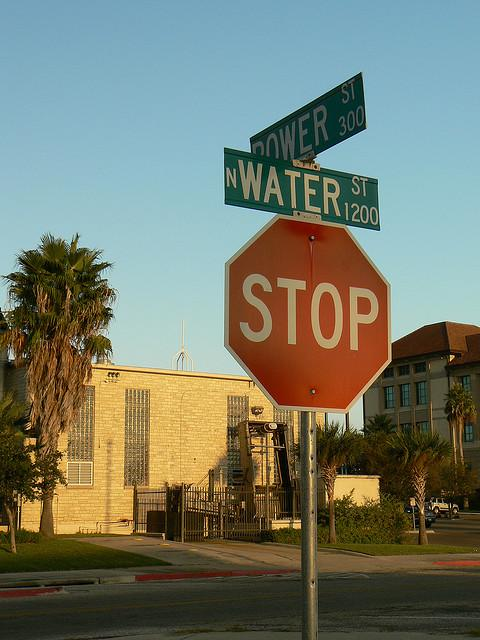What is next to the building? Please explain your reasoning. trees. The trees are near. 